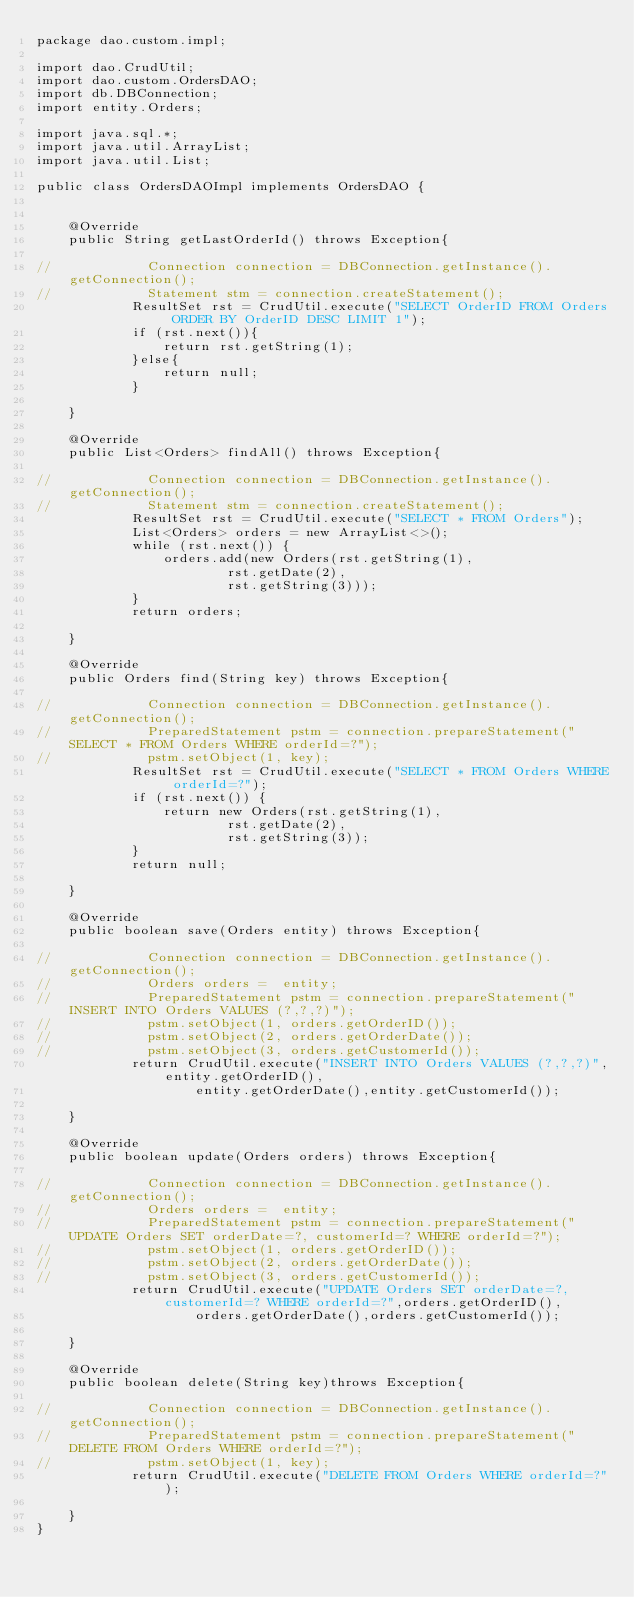Convert code to text. <code><loc_0><loc_0><loc_500><loc_500><_Java_>package dao.custom.impl;

import dao.CrudUtil;
import dao.custom.OrdersDAO;
import db.DBConnection;
import entity.Orders;

import java.sql.*;
import java.util.ArrayList;
import java.util.List;

public class OrdersDAOImpl implements OrdersDAO {


    @Override
    public String getLastOrderId() throws Exception{

//            Connection connection = DBConnection.getInstance().getConnection();
//            Statement stm = connection.createStatement();
            ResultSet rst = CrudUtil.execute("SELECT OrderID FROM Orders ORDER BY OrderID DESC LIMIT 1");
            if (rst.next()){
                return rst.getString(1);
            }else{
                return null;
            }

    }

    @Override
    public List<Orders> findAll() throws Exception{

//            Connection connection = DBConnection.getInstance().getConnection();
//            Statement stm = connection.createStatement();
            ResultSet rst = CrudUtil.execute("SELECT * FROM Orders");
            List<Orders> orders = new ArrayList<>();
            while (rst.next()) {
                orders.add(new Orders(rst.getString(1),
                        rst.getDate(2),
                        rst.getString(3)));
            }
            return orders;

    }

    @Override
    public Orders find(String key) throws Exception{

//            Connection connection = DBConnection.getInstance().getConnection();
//            PreparedStatement pstm = connection.prepareStatement("SELECT * FROM Orders WHERE orderId=?");
//            pstm.setObject(1, key);
            ResultSet rst = CrudUtil.execute("SELECT * FROM Orders WHERE orderId=?");
            if (rst.next()) {
                return new Orders(rst.getString(1),
                        rst.getDate(2),
                        rst.getString(3));
            }
            return null;

    }

    @Override
    public boolean save(Orders entity) throws Exception{

//            Connection connection = DBConnection.getInstance().getConnection();
//            Orders orders =  entity;
//            PreparedStatement pstm = connection.prepareStatement("INSERT INTO Orders VALUES (?,?,?)");
//            pstm.setObject(1, orders.getOrderID());
//            pstm.setObject(2, orders.getOrderDate());
//            pstm.setObject(3, orders.getCustomerId());
            return CrudUtil.execute("INSERT INTO Orders VALUES (?,?,?)",entity.getOrderID(),
                    entity.getOrderDate(),entity.getCustomerId());

    }

    @Override
    public boolean update(Orders orders) throws Exception{

//            Connection connection = DBConnection.getInstance().getConnection();
//            Orders orders =  entity;
//            PreparedStatement pstm = connection.prepareStatement("UPDATE Orders SET orderDate=?, customerId=? WHERE orderId=?");
//            pstm.setObject(1, orders.getOrderID());
//            pstm.setObject(2, orders.getOrderDate());
//            pstm.setObject(3, orders.getCustomerId());
            return CrudUtil.execute("UPDATE Orders SET orderDate=?, customerId=? WHERE orderId=?",orders.getOrderID(),
                    orders.getOrderDate(),orders.getCustomerId());

    }

    @Override
    public boolean delete(String key)throws Exception{

//            Connection connection = DBConnection.getInstance().getConnection();
//            PreparedStatement pstm = connection.prepareStatement("DELETE FROM Orders WHERE orderId=?");
//            pstm.setObject(1, key);
            return CrudUtil.execute("DELETE FROM Orders WHERE orderId=?");

    }
}
</code> 